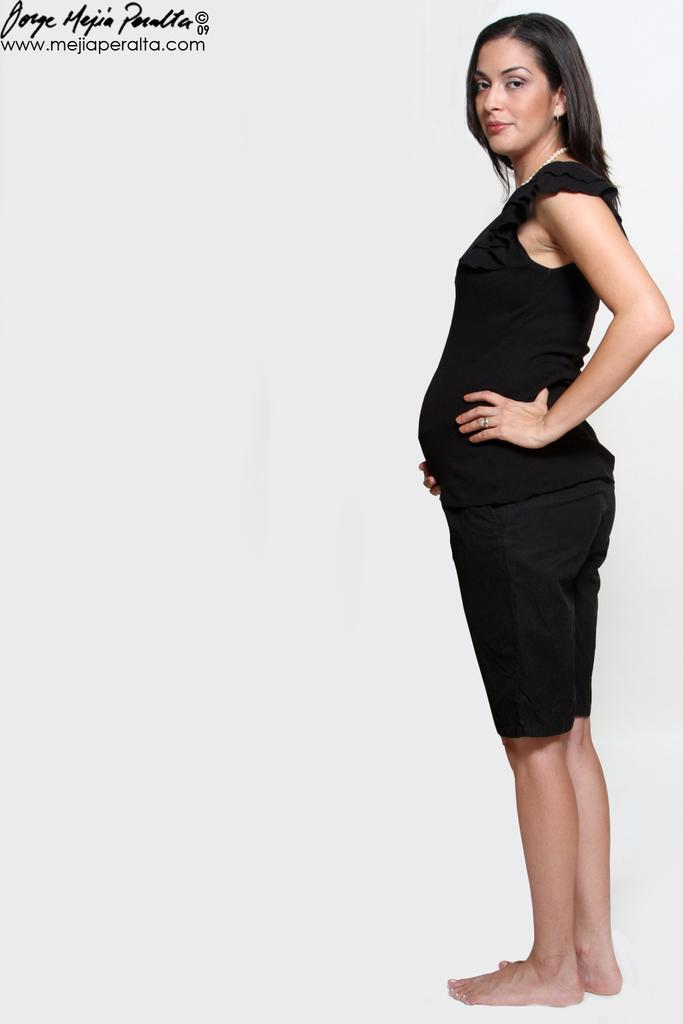What is the main subject of the image? There is a person in the image. Can you describe any text that is visible in the image? Yes, there is some text at the top of the image. Can you see any icicles hanging from the person's clothing in the image? There are no icicles visible in the image. What example does the text at the top of the image provide? The provided facts do not mention any specific example or context for the text, so it is not possible to answer this question. 